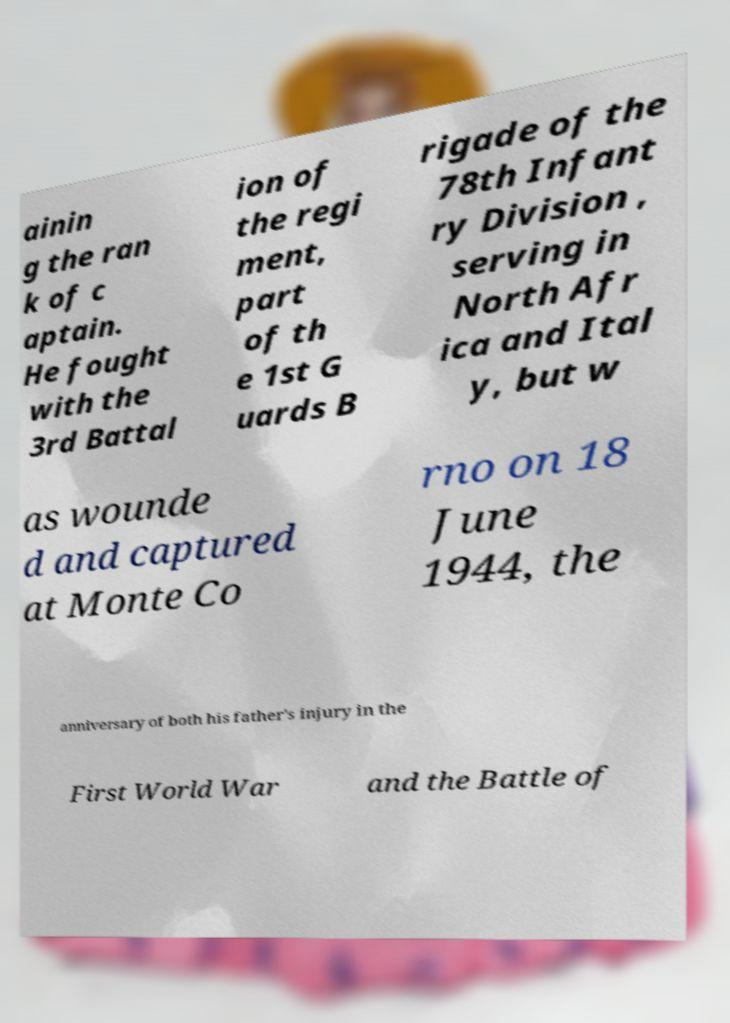I need the written content from this picture converted into text. Can you do that? ainin g the ran k of c aptain. He fought with the 3rd Battal ion of the regi ment, part of th e 1st G uards B rigade of the 78th Infant ry Division , serving in North Afr ica and Ital y, but w as wounde d and captured at Monte Co rno on 18 June 1944, the anniversary of both his father's injury in the First World War and the Battle of 